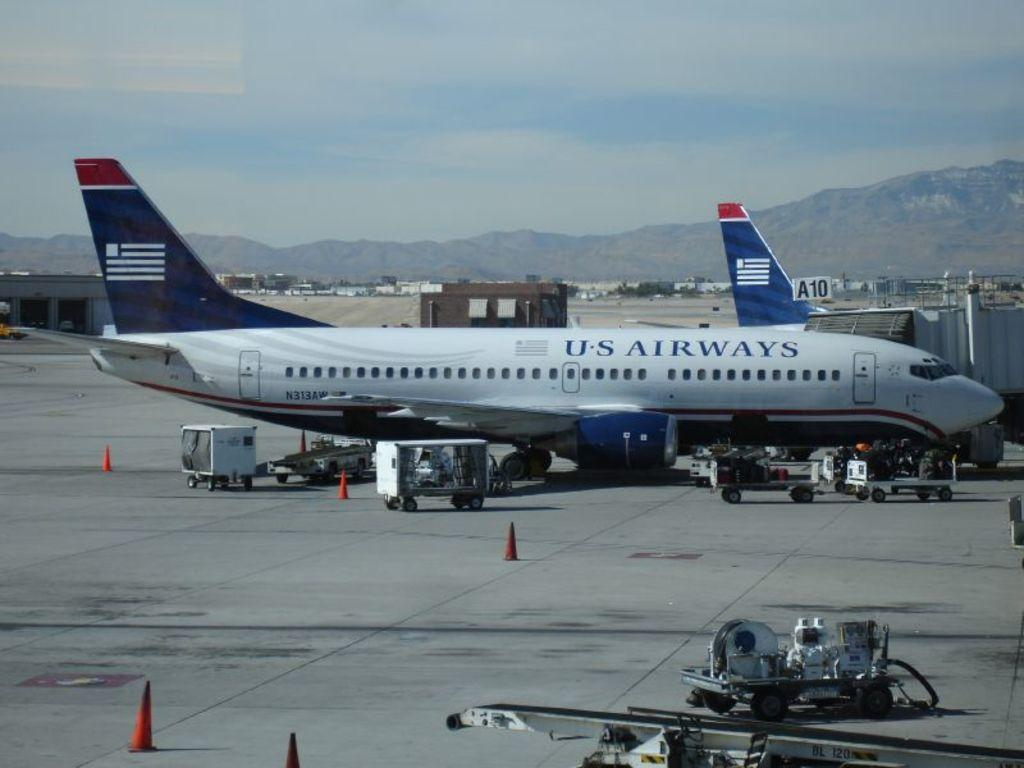Provide a one-sentence caption for the provided image. An US Airways airplane parked on the tarmac up against a terminal. 